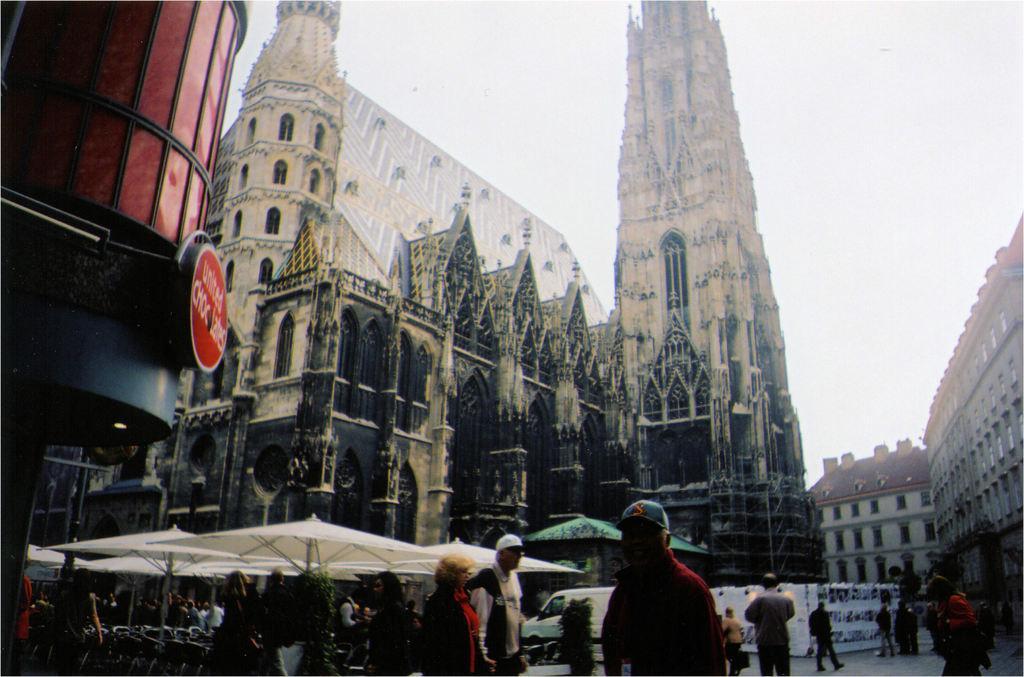In one or two sentences, can you explain what this image depicts? In this picture we can see few buildings, umbrellas and group of people, in the background we can see a van. 